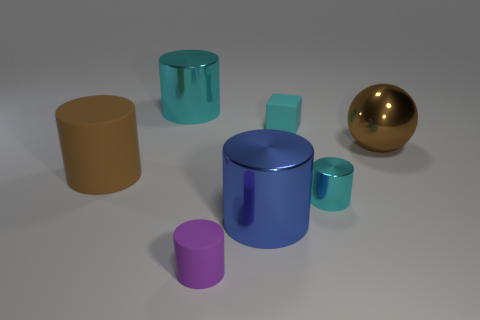Subtract 2 cylinders. How many cylinders are left? 3 Subtract all purple cylinders. How many cylinders are left? 4 Subtract all large cyan metallic cylinders. How many cylinders are left? 4 Subtract all green cylinders. Subtract all gray blocks. How many cylinders are left? 5 Add 1 blue cylinders. How many objects exist? 8 Subtract all balls. How many objects are left? 6 Subtract all rubber cylinders. Subtract all tiny cyan things. How many objects are left? 3 Add 5 large cyan shiny things. How many large cyan shiny things are left? 6 Add 3 big cyan shiny cylinders. How many big cyan shiny cylinders exist? 4 Subtract 0 blue cubes. How many objects are left? 7 